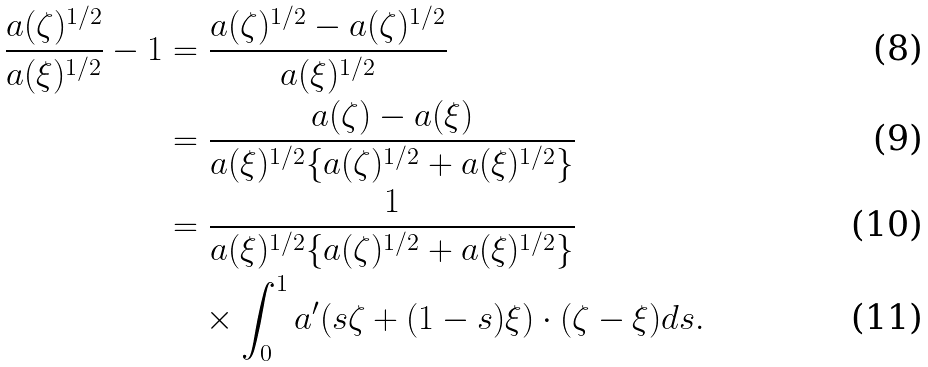Convert formula to latex. <formula><loc_0><loc_0><loc_500><loc_500>\frac { a ( \zeta ) ^ { 1 / 2 } } { a ( \xi ) ^ { 1 / 2 } } - 1 & = \frac { a ( \zeta ) ^ { 1 / 2 } - a ( \zeta ) ^ { 1 / 2 } } { a ( \xi ) ^ { 1 / 2 } } \\ & = \frac { a ( \zeta ) - a ( \xi ) } { a ( \xi ) ^ { 1 / 2 } \{ a ( \zeta ) ^ { 1 / 2 } + a ( \xi ) ^ { 1 / 2 } \} } \\ & = \frac { 1 } { a ( \xi ) ^ { 1 / 2 } \{ a ( \zeta ) ^ { 1 / 2 } + a ( \xi ) ^ { 1 / 2 } \} } \\ & \quad \times \int _ { 0 } ^ { 1 } a ^ { \prime } ( s \zeta + ( 1 - s ) \xi ) \cdot ( \zeta - \xi ) d s .</formula> 